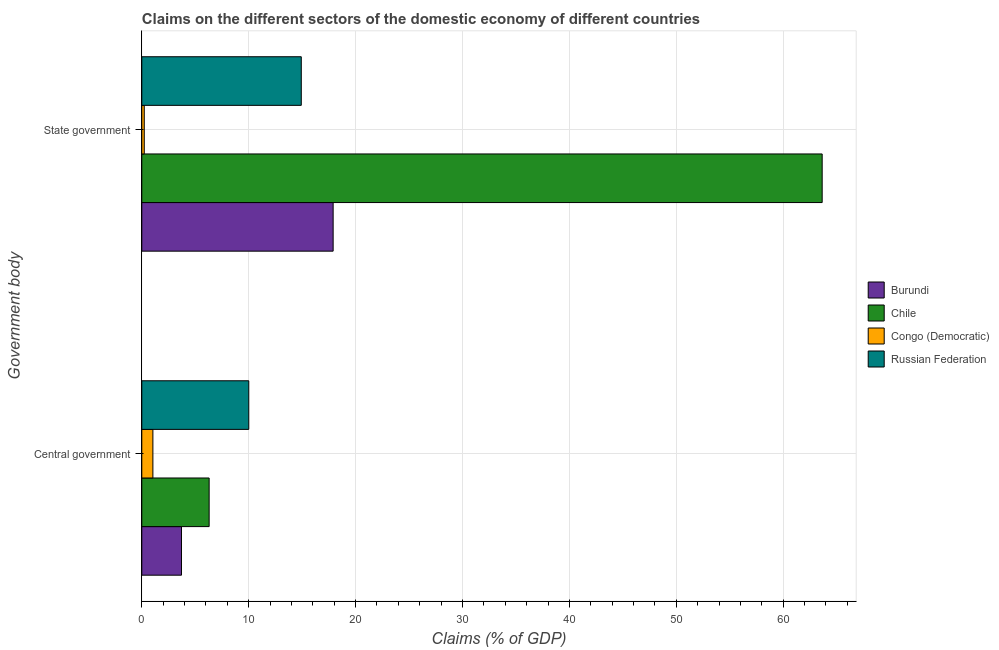How many different coloured bars are there?
Your answer should be very brief. 4. How many bars are there on the 1st tick from the bottom?
Ensure brevity in your answer.  4. What is the label of the 1st group of bars from the top?
Offer a terse response. State government. What is the claims on state government in Congo (Democratic)?
Give a very brief answer. 0.23. Across all countries, what is the maximum claims on state government?
Provide a succinct answer. 63.64. Across all countries, what is the minimum claims on central government?
Give a very brief answer. 1.04. In which country was the claims on state government maximum?
Your response must be concise. Chile. In which country was the claims on state government minimum?
Make the answer very short. Congo (Democratic). What is the total claims on central government in the graph?
Ensure brevity in your answer.  21.06. What is the difference between the claims on state government in Burundi and that in Chile?
Ensure brevity in your answer.  -45.74. What is the difference between the claims on central government in Congo (Democratic) and the claims on state government in Russian Federation?
Your answer should be very brief. -13.88. What is the average claims on central government per country?
Offer a terse response. 5.26. What is the difference between the claims on central government and claims on state government in Congo (Democratic)?
Your answer should be very brief. 0.81. In how many countries, is the claims on state government greater than 48 %?
Provide a succinct answer. 1. What is the ratio of the claims on state government in Chile to that in Burundi?
Offer a very short reply. 3.56. In how many countries, is the claims on central government greater than the average claims on central government taken over all countries?
Make the answer very short. 2. What does the 1st bar from the top in Central government represents?
Provide a short and direct response. Russian Federation. What does the 3rd bar from the bottom in Central government represents?
Make the answer very short. Congo (Democratic). How many countries are there in the graph?
Your response must be concise. 4. What is the difference between two consecutive major ticks on the X-axis?
Make the answer very short. 10. Does the graph contain grids?
Offer a very short reply. Yes. How are the legend labels stacked?
Provide a succinct answer. Vertical. What is the title of the graph?
Give a very brief answer. Claims on the different sectors of the domestic economy of different countries. What is the label or title of the X-axis?
Keep it short and to the point. Claims (% of GDP). What is the label or title of the Y-axis?
Keep it short and to the point. Government body. What is the Claims (% of GDP) of Burundi in Central government?
Keep it short and to the point. 3.71. What is the Claims (% of GDP) of Chile in Central government?
Your answer should be very brief. 6.3. What is the Claims (% of GDP) in Congo (Democratic) in Central government?
Offer a terse response. 1.04. What is the Claims (% of GDP) in Russian Federation in Central government?
Offer a terse response. 10.01. What is the Claims (% of GDP) of Burundi in State government?
Your response must be concise. 17.9. What is the Claims (% of GDP) in Chile in State government?
Your answer should be very brief. 63.64. What is the Claims (% of GDP) of Congo (Democratic) in State government?
Offer a very short reply. 0.23. What is the Claims (% of GDP) of Russian Federation in State government?
Your response must be concise. 14.92. Across all Government body, what is the maximum Claims (% of GDP) in Burundi?
Offer a very short reply. 17.9. Across all Government body, what is the maximum Claims (% of GDP) of Chile?
Your response must be concise. 63.64. Across all Government body, what is the maximum Claims (% of GDP) in Congo (Democratic)?
Offer a very short reply. 1.04. Across all Government body, what is the maximum Claims (% of GDP) in Russian Federation?
Provide a succinct answer. 14.92. Across all Government body, what is the minimum Claims (% of GDP) in Burundi?
Your answer should be very brief. 3.71. Across all Government body, what is the minimum Claims (% of GDP) in Chile?
Ensure brevity in your answer.  6.3. Across all Government body, what is the minimum Claims (% of GDP) of Congo (Democratic)?
Your response must be concise. 0.23. Across all Government body, what is the minimum Claims (% of GDP) in Russian Federation?
Your answer should be compact. 10.01. What is the total Claims (% of GDP) in Burundi in the graph?
Keep it short and to the point. 21.61. What is the total Claims (% of GDP) in Chile in the graph?
Make the answer very short. 69.94. What is the total Claims (% of GDP) in Congo (Democratic) in the graph?
Keep it short and to the point. 1.27. What is the total Claims (% of GDP) in Russian Federation in the graph?
Provide a succinct answer. 24.93. What is the difference between the Claims (% of GDP) in Burundi in Central government and that in State government?
Your answer should be compact. -14.19. What is the difference between the Claims (% of GDP) of Chile in Central government and that in State government?
Offer a very short reply. -57.34. What is the difference between the Claims (% of GDP) in Congo (Democratic) in Central government and that in State government?
Give a very brief answer. 0.81. What is the difference between the Claims (% of GDP) of Russian Federation in Central government and that in State government?
Ensure brevity in your answer.  -4.91. What is the difference between the Claims (% of GDP) of Burundi in Central government and the Claims (% of GDP) of Chile in State government?
Provide a short and direct response. -59.93. What is the difference between the Claims (% of GDP) in Burundi in Central government and the Claims (% of GDP) in Congo (Democratic) in State government?
Keep it short and to the point. 3.48. What is the difference between the Claims (% of GDP) in Burundi in Central government and the Claims (% of GDP) in Russian Federation in State government?
Give a very brief answer. -11.21. What is the difference between the Claims (% of GDP) of Chile in Central government and the Claims (% of GDP) of Congo (Democratic) in State government?
Provide a succinct answer. 6.07. What is the difference between the Claims (% of GDP) in Chile in Central government and the Claims (% of GDP) in Russian Federation in State government?
Offer a very short reply. -8.62. What is the difference between the Claims (% of GDP) of Congo (Democratic) in Central government and the Claims (% of GDP) of Russian Federation in State government?
Offer a terse response. -13.88. What is the average Claims (% of GDP) in Burundi per Government body?
Your answer should be very brief. 10.81. What is the average Claims (% of GDP) in Chile per Government body?
Your response must be concise. 34.97. What is the average Claims (% of GDP) of Congo (Democratic) per Government body?
Provide a succinct answer. 0.63. What is the average Claims (% of GDP) of Russian Federation per Government body?
Your answer should be compact. 12.46. What is the difference between the Claims (% of GDP) of Burundi and Claims (% of GDP) of Chile in Central government?
Keep it short and to the point. -2.59. What is the difference between the Claims (% of GDP) in Burundi and Claims (% of GDP) in Congo (Democratic) in Central government?
Your response must be concise. 2.67. What is the difference between the Claims (% of GDP) of Burundi and Claims (% of GDP) of Russian Federation in Central government?
Make the answer very short. -6.3. What is the difference between the Claims (% of GDP) of Chile and Claims (% of GDP) of Congo (Democratic) in Central government?
Keep it short and to the point. 5.26. What is the difference between the Claims (% of GDP) in Chile and Claims (% of GDP) in Russian Federation in Central government?
Provide a short and direct response. -3.71. What is the difference between the Claims (% of GDP) of Congo (Democratic) and Claims (% of GDP) of Russian Federation in Central government?
Your answer should be compact. -8.97. What is the difference between the Claims (% of GDP) of Burundi and Claims (% of GDP) of Chile in State government?
Offer a very short reply. -45.74. What is the difference between the Claims (% of GDP) in Burundi and Claims (% of GDP) in Congo (Democratic) in State government?
Your response must be concise. 17.67. What is the difference between the Claims (% of GDP) of Burundi and Claims (% of GDP) of Russian Federation in State government?
Your answer should be compact. 2.98. What is the difference between the Claims (% of GDP) of Chile and Claims (% of GDP) of Congo (Democratic) in State government?
Offer a terse response. 63.41. What is the difference between the Claims (% of GDP) of Chile and Claims (% of GDP) of Russian Federation in State government?
Offer a very short reply. 48.73. What is the difference between the Claims (% of GDP) in Congo (Democratic) and Claims (% of GDP) in Russian Federation in State government?
Keep it short and to the point. -14.69. What is the ratio of the Claims (% of GDP) of Burundi in Central government to that in State government?
Offer a terse response. 0.21. What is the ratio of the Claims (% of GDP) of Chile in Central government to that in State government?
Your answer should be compact. 0.1. What is the ratio of the Claims (% of GDP) in Congo (Democratic) in Central government to that in State government?
Keep it short and to the point. 4.51. What is the ratio of the Claims (% of GDP) in Russian Federation in Central government to that in State government?
Your response must be concise. 0.67. What is the difference between the highest and the second highest Claims (% of GDP) in Burundi?
Offer a very short reply. 14.19. What is the difference between the highest and the second highest Claims (% of GDP) of Chile?
Offer a terse response. 57.34. What is the difference between the highest and the second highest Claims (% of GDP) of Congo (Democratic)?
Provide a succinct answer. 0.81. What is the difference between the highest and the second highest Claims (% of GDP) in Russian Federation?
Make the answer very short. 4.91. What is the difference between the highest and the lowest Claims (% of GDP) in Burundi?
Your answer should be very brief. 14.19. What is the difference between the highest and the lowest Claims (% of GDP) of Chile?
Ensure brevity in your answer.  57.34. What is the difference between the highest and the lowest Claims (% of GDP) of Congo (Democratic)?
Your response must be concise. 0.81. What is the difference between the highest and the lowest Claims (% of GDP) in Russian Federation?
Your response must be concise. 4.91. 